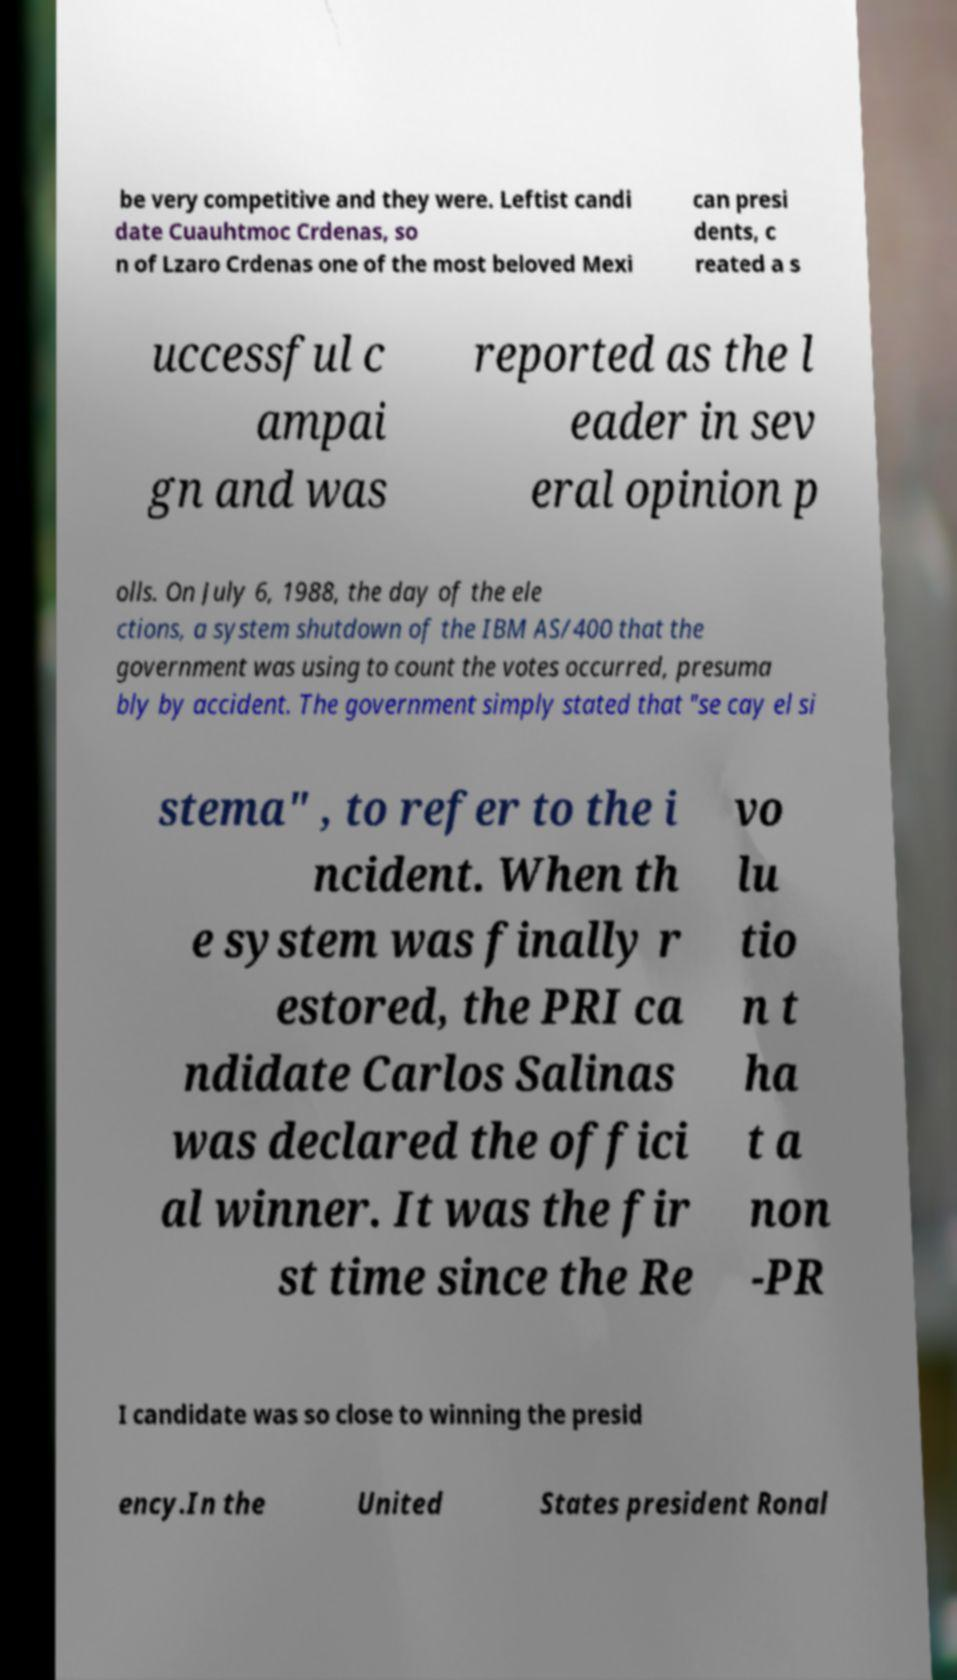Could you extract and type out the text from this image? be very competitive and they were. Leftist candi date Cuauhtmoc Crdenas, so n of Lzaro Crdenas one of the most beloved Mexi can presi dents, c reated a s uccessful c ampai gn and was reported as the l eader in sev eral opinion p olls. On July 6, 1988, the day of the ele ctions, a system shutdown of the IBM AS/400 that the government was using to count the votes occurred, presuma bly by accident. The government simply stated that "se cay el si stema" , to refer to the i ncident. When th e system was finally r estored, the PRI ca ndidate Carlos Salinas was declared the offici al winner. It was the fir st time since the Re vo lu tio n t ha t a non -PR I candidate was so close to winning the presid ency.In the United States president Ronal 